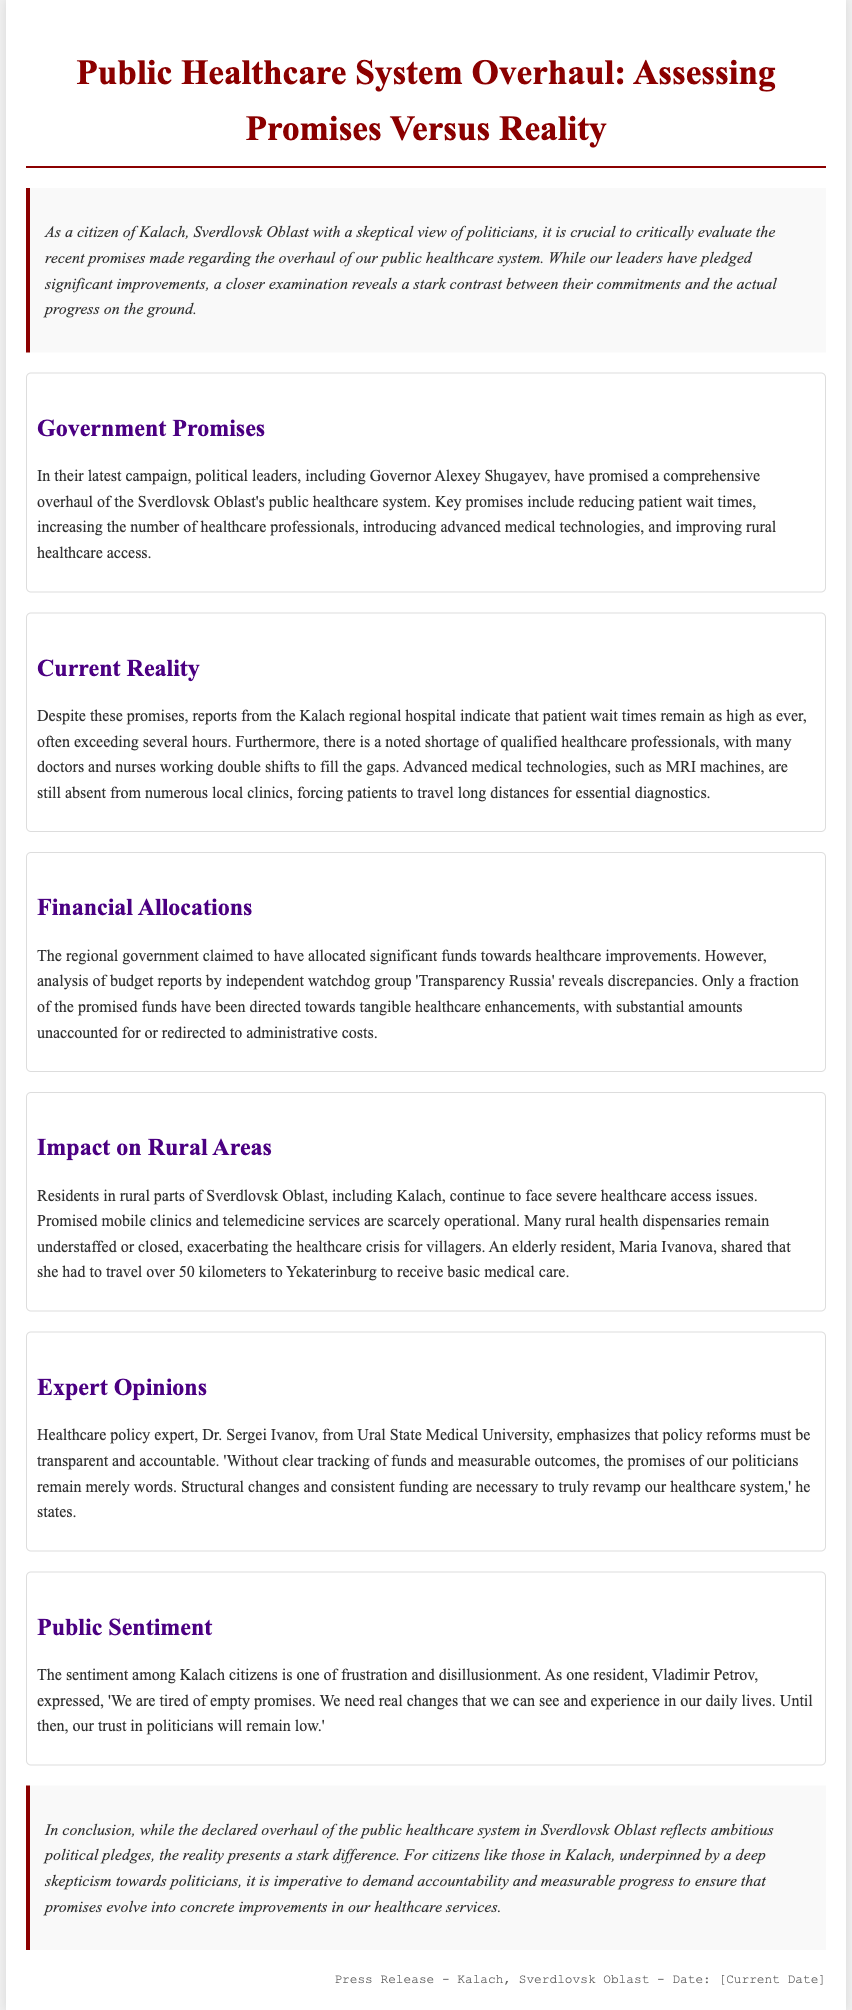What are the key promises made by political leaders? The section on Government Promises outlines commitments such as reducing patient wait times, increasing healthcare professionals, introducing advanced medical technologies, and improving rural healthcare access.
Answer: Reducing patient wait times, increasing healthcare professionals, introducing advanced medical technologies, improving rural healthcare access What is the reported patient wait time in Kalach regional hospital? In the Current Reality section, it mentions that patient wait times often exceed several hours at the Kalach regional hospital.
Answer: Several hours Who is the governor mentioned in the press release? The Government Promises section highlights Governor Alexey Shugayev as one of the political leaders making promises regarding the healthcare system.
Answer: Alexey Shugayev What issues do rural residents face regarding healthcare access? The Impact on Rural Areas section describes that rural residents continue to face severe healthcare access issues, with mobile clinics and telemedicine services scarcely operational.
Answer: Severe healthcare access issues What does Dr. Sergei Ivanov emphasize about healthcare policy reforms? In the Expert Opinions section, Dr. Sergei Ivanov stresses the importance of transparency and accountability in policy reforms, stating that without tracking of funds and measurable outcomes, promises remain mere words.
Answer: Transparency and accountability How do Kalach citizens feel about the government's promises? The Public Sentiment section conveys frustration and disillusionment among Kalach citizens regarding the government's promises, as expressed by resident Vladimir Petrov.
Answer: Frustration and disillusionment What organization analyzed the budget reports related to healthcare funding? The Financial Allocations section mentions that the independent watchdog group 'Transparency Russia' analyzed the budget reports.
Answer: Transparency Russia 